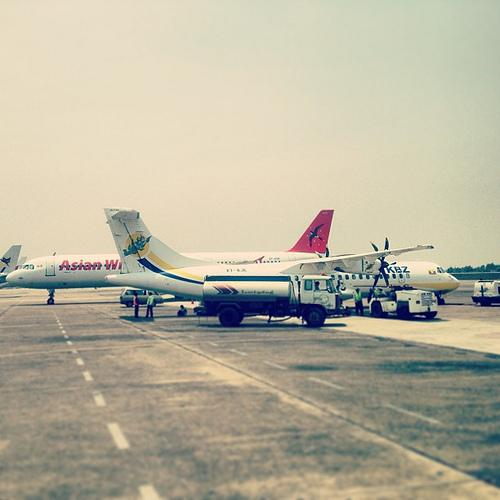What is the general sentiment or vibe that this image conveys? The image conveys a productive and busy atmosphere at an airport, with various activities taking place around the planes. Explain how the objects in this image interact with each other, citing specific examples. The gas truck interacts with the airplane it's fueling, while people nearby perform maintenance or other tasks in relation to the planes. Mention the process taking place between an aircraft and a ground vehicle. A gas truck fuels an airplane, providing the necessary energy for it to embark on its next flight. What is the primary focus of this image and what activity is taking place? The primary focus is on two airplanes parked on a runway and receiving fuel, surrounded by trucks and people. Can you identify any unique features or markings on the airplanes in the image? One airplane has red writing on its side, and another has a white color with one yellow and one blue stripe. What can you deduce about the quality of the image based on the given information about the objects in it? The image seems to be of good quality, with clear details and precise measurements of objects, allowing for effective object detection and interaction analysis. Enumerate the two primary subjects in the image and their attributes. Two large airplanes parked on the tarmac with different markings, and a runway with planes, trucks, and people surrounding it. How many people can you identify in the image, and where are they in relation to the airplanes? There are two people standing near the airplanes, one pair below an airplane and another beside an airplane. Give a poetic description of the sky in the image. The sky paints a vast canvas of azure blue, dotted with whimsical white clouds, casting a cheerful light upon the bustling runway. What is the color of the writing on the side of the airplane? red Can you see any weather radar equipment near a plane? There should be some near the wings. There is no mention of weather radar equipment in the given information about the image. This instruction is misleading because it asks the viewer to search for something that doesn't exist in the image. Is this a busy or quiet scene at the airport? It is a moderately busy scene. Find the helicopter hovering just above the planes. The helicopter is quite hard to spot, but it's there. This instruction is misleading because the image only contains information about airplanes and a runway. There's no mention of a helicopter, so it is not present in the image. Describe the appearance of the fuel truck in the image. The fuel truck is large and positioned in front of the airplane. What event could be happening at this location? Airplanes are getting refueled and prepared for their next flight. Come up with a mottos for this airport scene. "Fueling for the Future: A Day in the Life at the Runway" Label the main components of the image's planes. cockpit, wings, tail fin, propeller, wheels What is the activity occurring near the airplane? An airplane is receiving fuel, and people are standing near the planes. What type of vehicles can you find on this image? planes, trucks Can you spot the tiny green tree near the edge of the runway? There isn't any greenery in this image. This is misleading because there's no mention of a tree or any greenery in the given information about the image. The presence of the tree would not correspond to the image. Do the planes in the image appear to be the same or different in size? The planes appear to be the same size. Write a sentence using an analogy about the size of the planes. The planes are as huge as the clear blue sky above them. Create a news headline for this image. Airplanes Receive Fuel in Perfect Weather on a Clear Day at the Runway Do you see the group of birds flying in the sky? They can be seen just above one of the planes. There is no mention of birds in the given information about the image. This instruction is misleading because it asks the viewer to search for something that doesn't exist in the image. What emotions can you infer from the people near the airplane? Cannot determine emotions - facial expressions not visible Based on the people's postures, can we infer their emotions? Cannot infer emotions – facial expressions not visible How many clouds are in the sky? There are no clouds. What is the main activity happening near the airplanes? Fueling the airplanes Notice the hot air balloon floating in the distance. The hot air balloon adds a calm aspect to the otherwise busy image. This instruction is misleading because there's no mention of a hot air balloon in the given information about the image. The viewer would be looking for something that doesn't exist in the image. Look for the control tower on the left side of the image. You can see it overlooking the airplanes. This is misleading because there's no mention of a control tower in the given information about the image. The presence of the control tower would not correspond to the image. Is the sky blue, cloudy or clear in this image? clear skies Describe the colors on the airplanes' tail fins. There are red stabilizers and white tail fins. Write a descriptive sentence about the planes being refueled. A gas truck is fueling two large airplanes parked on the tarmac. Can you spot any text written on the side of the airplane? Yes, there is red writing on the side of the airplane. Identify the main parts of the airplane. cockpit, propeller, tail fin, wings, wheels 